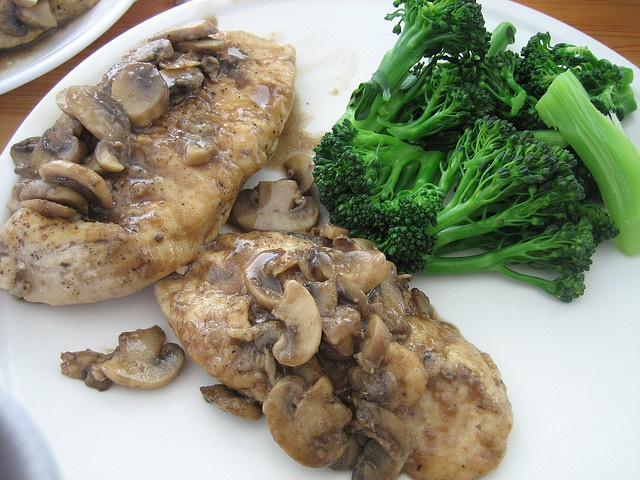Describe the objects in this image and their specific colors. I can see broccoli in brown, darkgreen, black, and green tones and dining table in brown and lightgray tones in this image. 